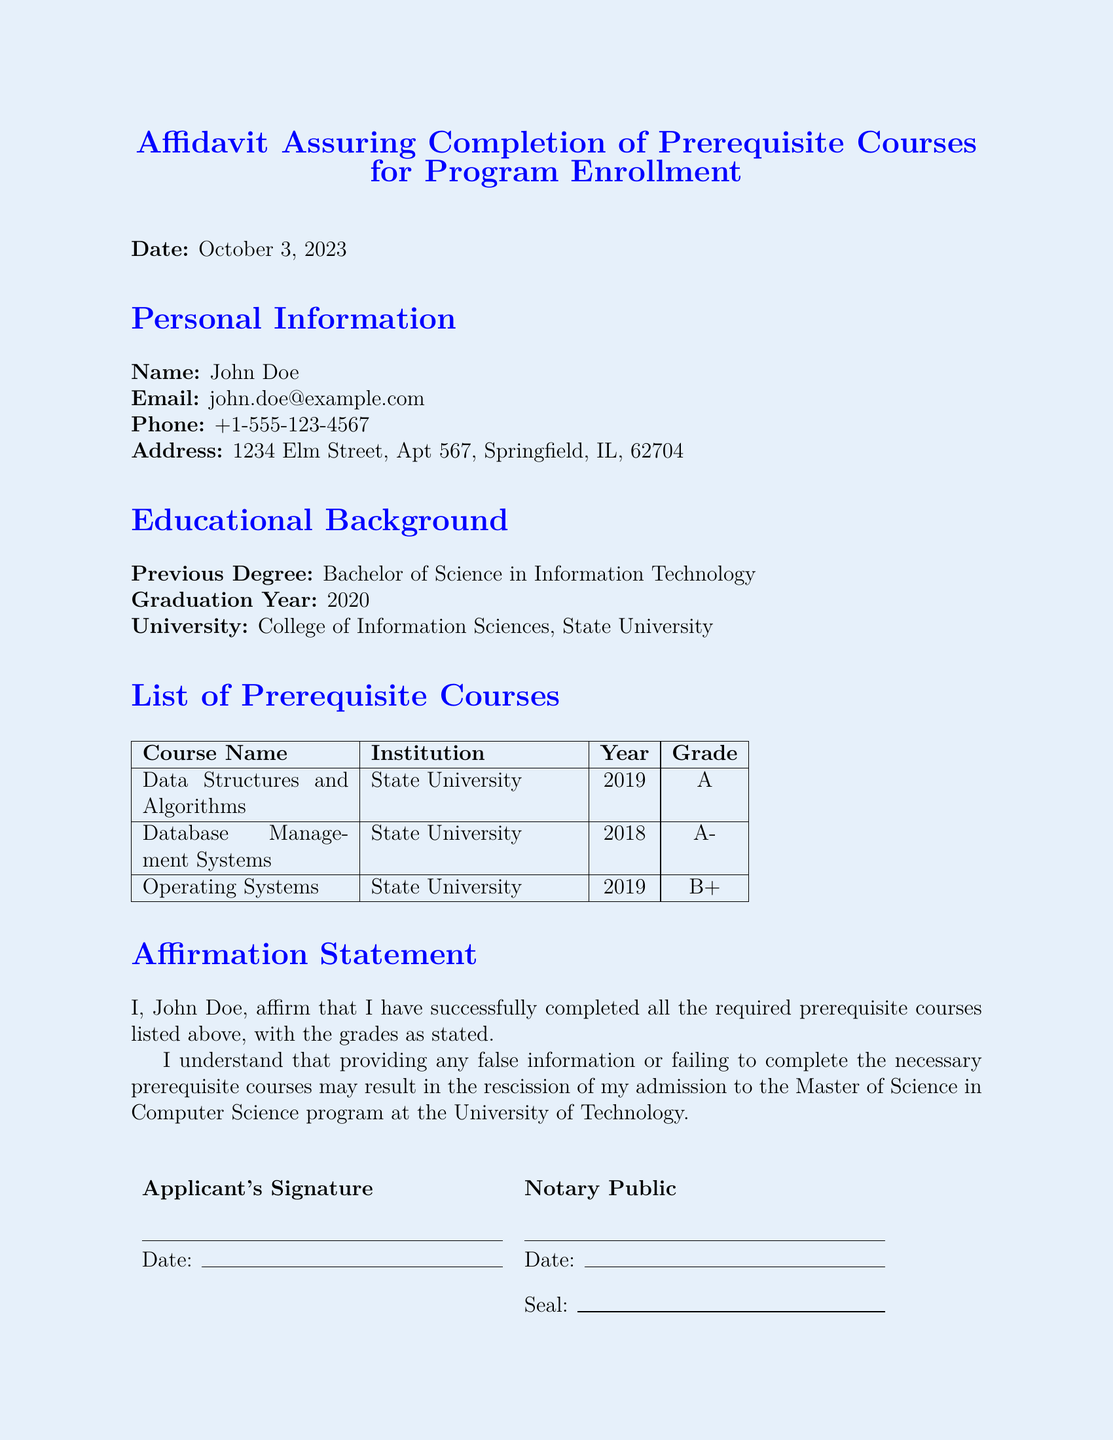What is the date of the affidavit? The date is stated in the document under the 'Date:' section.
Answer: October 3, 2023 Who is the applicant? The applicant's name is listed at the top of the personal information section.
Answer: John Doe What is the previous degree earned by the applicant? This information is found in the educational background section of the document.
Answer: Bachelor of Science in Information Technology What grade did the applicant receive in Database Management Systems? The grade is provided in the table listing the prerequisite courses.
Answer: A- Which institution awarded the previous degree? The university name is listed under the educational background section.
Answer: College of Information Sciences, State University How many prerequisite courses are listed? The document contains a table with courses listed, indicating their total.
Answer: 3 What is the affirmation statement about? The affirmation statement indicates the applicant's completion of the required courses.
Answer: Completion of required prerequisite courses What might happen if the applicant provides false information? This consequence is also mentioned in the affirmation statement part of the document.
Answer: Rescission of admission What is the signature requirement section for? This section is for the applicant and the notary public to sign as part of the affidavit process.
Answer: Applicant's and Notary Public's signatures 